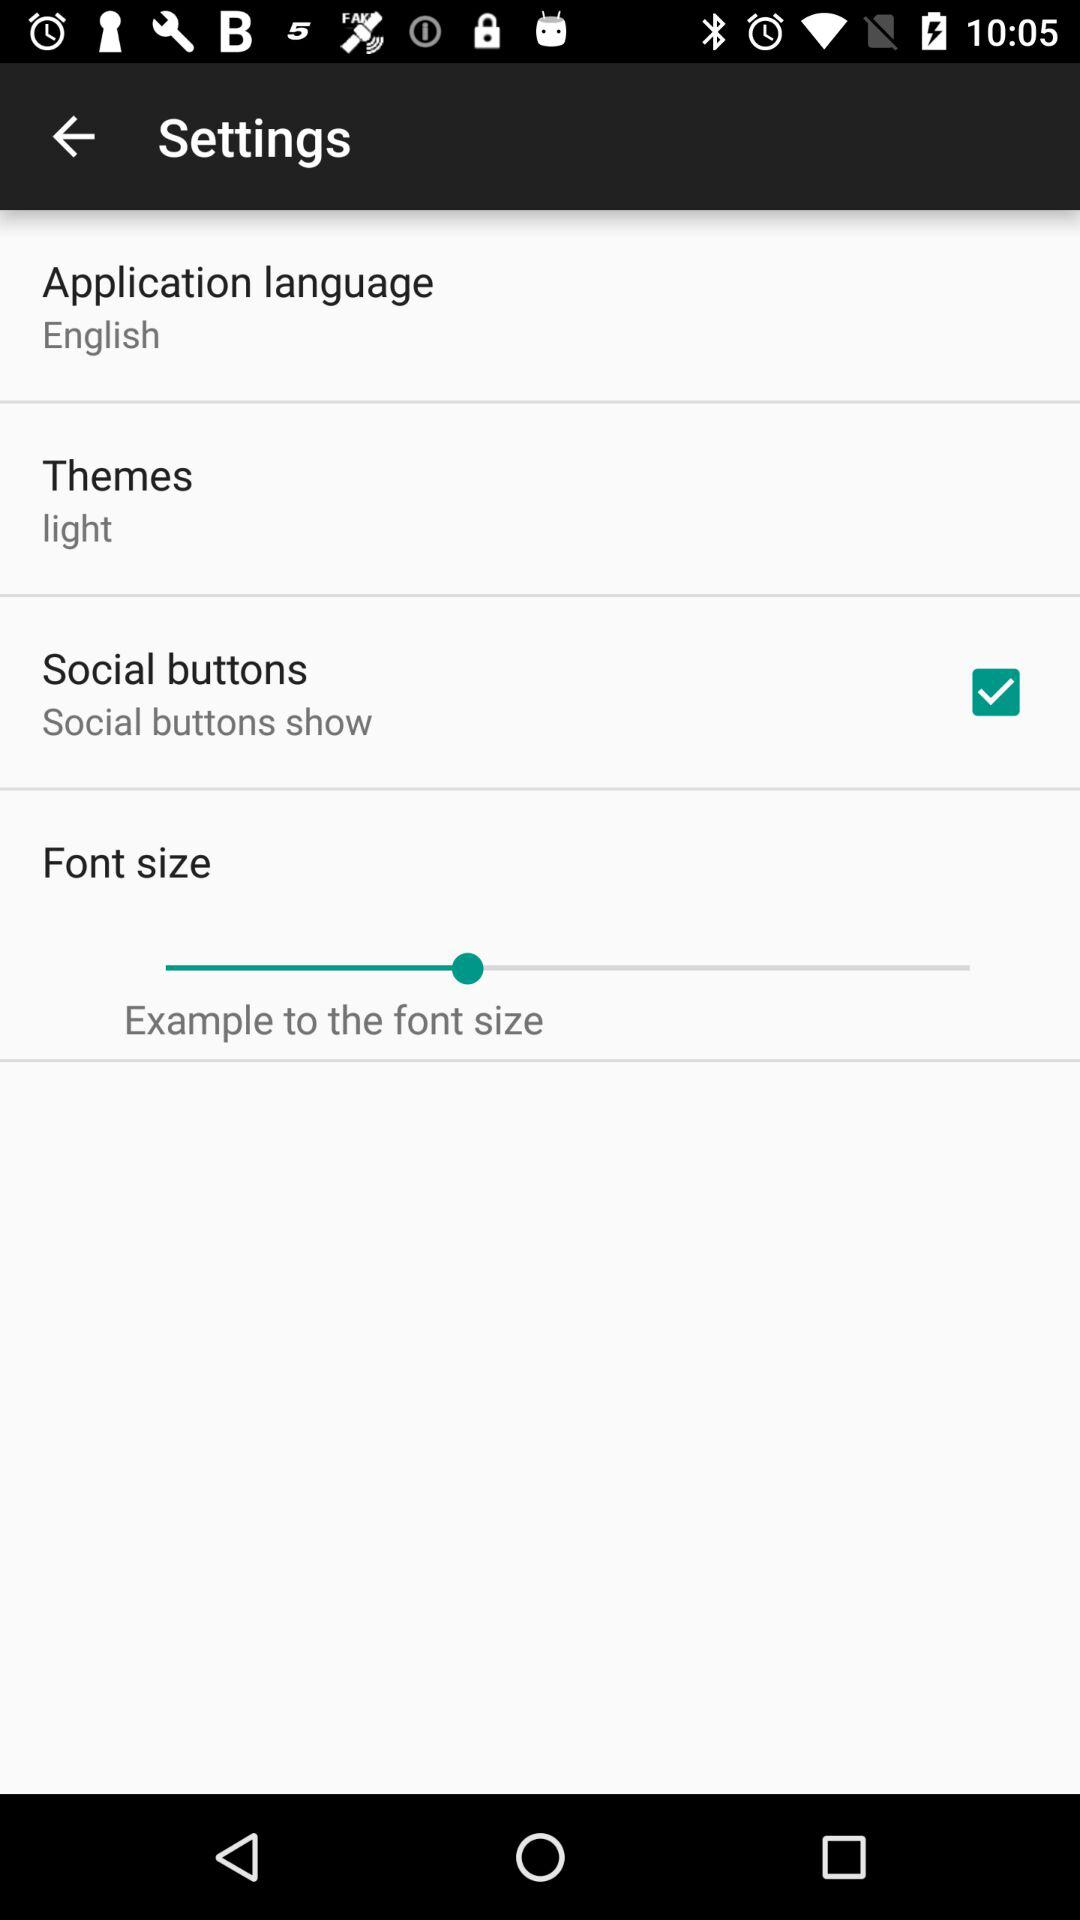What is the status of the "Social buttons"? The status is "on". 